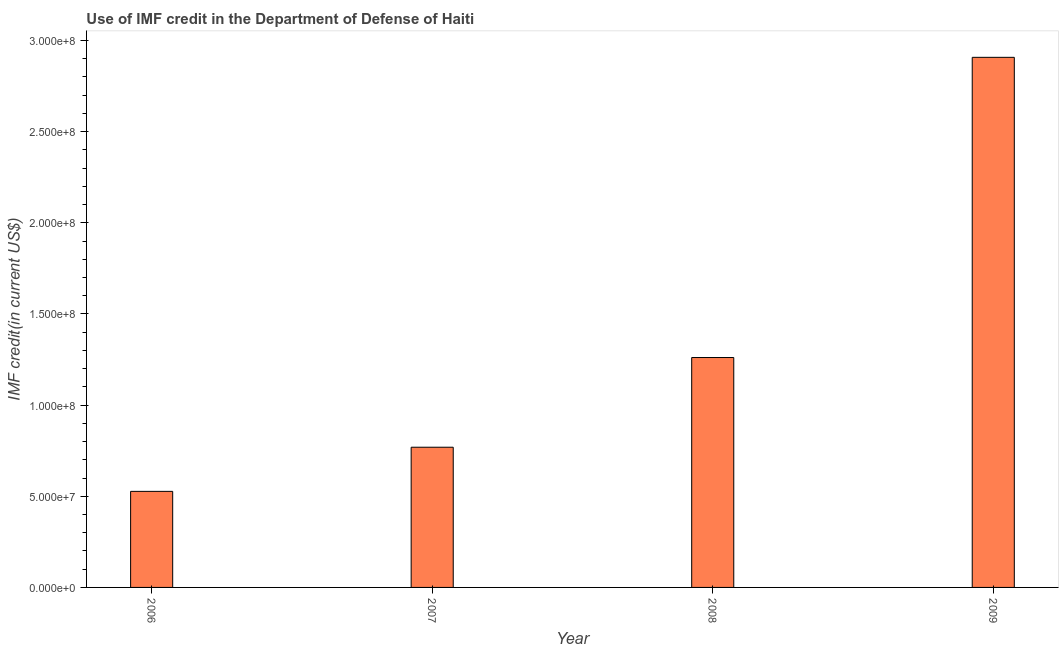Does the graph contain grids?
Your response must be concise. No. What is the title of the graph?
Offer a very short reply. Use of IMF credit in the Department of Defense of Haiti. What is the label or title of the Y-axis?
Your answer should be very brief. IMF credit(in current US$). What is the use of imf credit in dod in 2006?
Give a very brief answer. 5.27e+07. Across all years, what is the maximum use of imf credit in dod?
Offer a terse response. 2.91e+08. Across all years, what is the minimum use of imf credit in dod?
Your response must be concise. 5.27e+07. In which year was the use of imf credit in dod maximum?
Make the answer very short. 2009. In which year was the use of imf credit in dod minimum?
Give a very brief answer. 2006. What is the sum of the use of imf credit in dod?
Offer a terse response. 5.46e+08. What is the difference between the use of imf credit in dod in 2007 and 2009?
Make the answer very short. -2.14e+08. What is the average use of imf credit in dod per year?
Provide a succinct answer. 1.37e+08. What is the median use of imf credit in dod?
Provide a succinct answer. 1.01e+08. In how many years, is the use of imf credit in dod greater than 40000000 US$?
Your response must be concise. 4. Do a majority of the years between 2008 and 2006 (inclusive) have use of imf credit in dod greater than 140000000 US$?
Your answer should be compact. Yes. What is the ratio of the use of imf credit in dod in 2006 to that in 2008?
Offer a terse response. 0.42. Is the use of imf credit in dod in 2006 less than that in 2007?
Offer a terse response. Yes. What is the difference between the highest and the second highest use of imf credit in dod?
Provide a succinct answer. 1.65e+08. What is the difference between the highest and the lowest use of imf credit in dod?
Keep it short and to the point. 2.38e+08. In how many years, is the use of imf credit in dod greater than the average use of imf credit in dod taken over all years?
Make the answer very short. 1. How many bars are there?
Ensure brevity in your answer.  4. Are all the bars in the graph horizontal?
Make the answer very short. No. What is the difference between two consecutive major ticks on the Y-axis?
Provide a short and direct response. 5.00e+07. Are the values on the major ticks of Y-axis written in scientific E-notation?
Keep it short and to the point. Yes. What is the IMF credit(in current US$) of 2006?
Offer a very short reply. 5.27e+07. What is the IMF credit(in current US$) of 2007?
Provide a short and direct response. 7.69e+07. What is the IMF credit(in current US$) of 2008?
Provide a succinct answer. 1.26e+08. What is the IMF credit(in current US$) in 2009?
Provide a succinct answer. 2.91e+08. What is the difference between the IMF credit(in current US$) in 2006 and 2007?
Make the answer very short. -2.42e+07. What is the difference between the IMF credit(in current US$) in 2006 and 2008?
Provide a succinct answer. -7.34e+07. What is the difference between the IMF credit(in current US$) in 2006 and 2009?
Provide a succinct answer. -2.38e+08. What is the difference between the IMF credit(in current US$) in 2007 and 2008?
Offer a very short reply. -4.92e+07. What is the difference between the IMF credit(in current US$) in 2007 and 2009?
Offer a terse response. -2.14e+08. What is the difference between the IMF credit(in current US$) in 2008 and 2009?
Provide a succinct answer. -1.65e+08. What is the ratio of the IMF credit(in current US$) in 2006 to that in 2007?
Give a very brief answer. 0.69. What is the ratio of the IMF credit(in current US$) in 2006 to that in 2008?
Provide a succinct answer. 0.42. What is the ratio of the IMF credit(in current US$) in 2006 to that in 2009?
Offer a very short reply. 0.18. What is the ratio of the IMF credit(in current US$) in 2007 to that in 2008?
Give a very brief answer. 0.61. What is the ratio of the IMF credit(in current US$) in 2007 to that in 2009?
Provide a succinct answer. 0.26. What is the ratio of the IMF credit(in current US$) in 2008 to that in 2009?
Offer a very short reply. 0.43. 